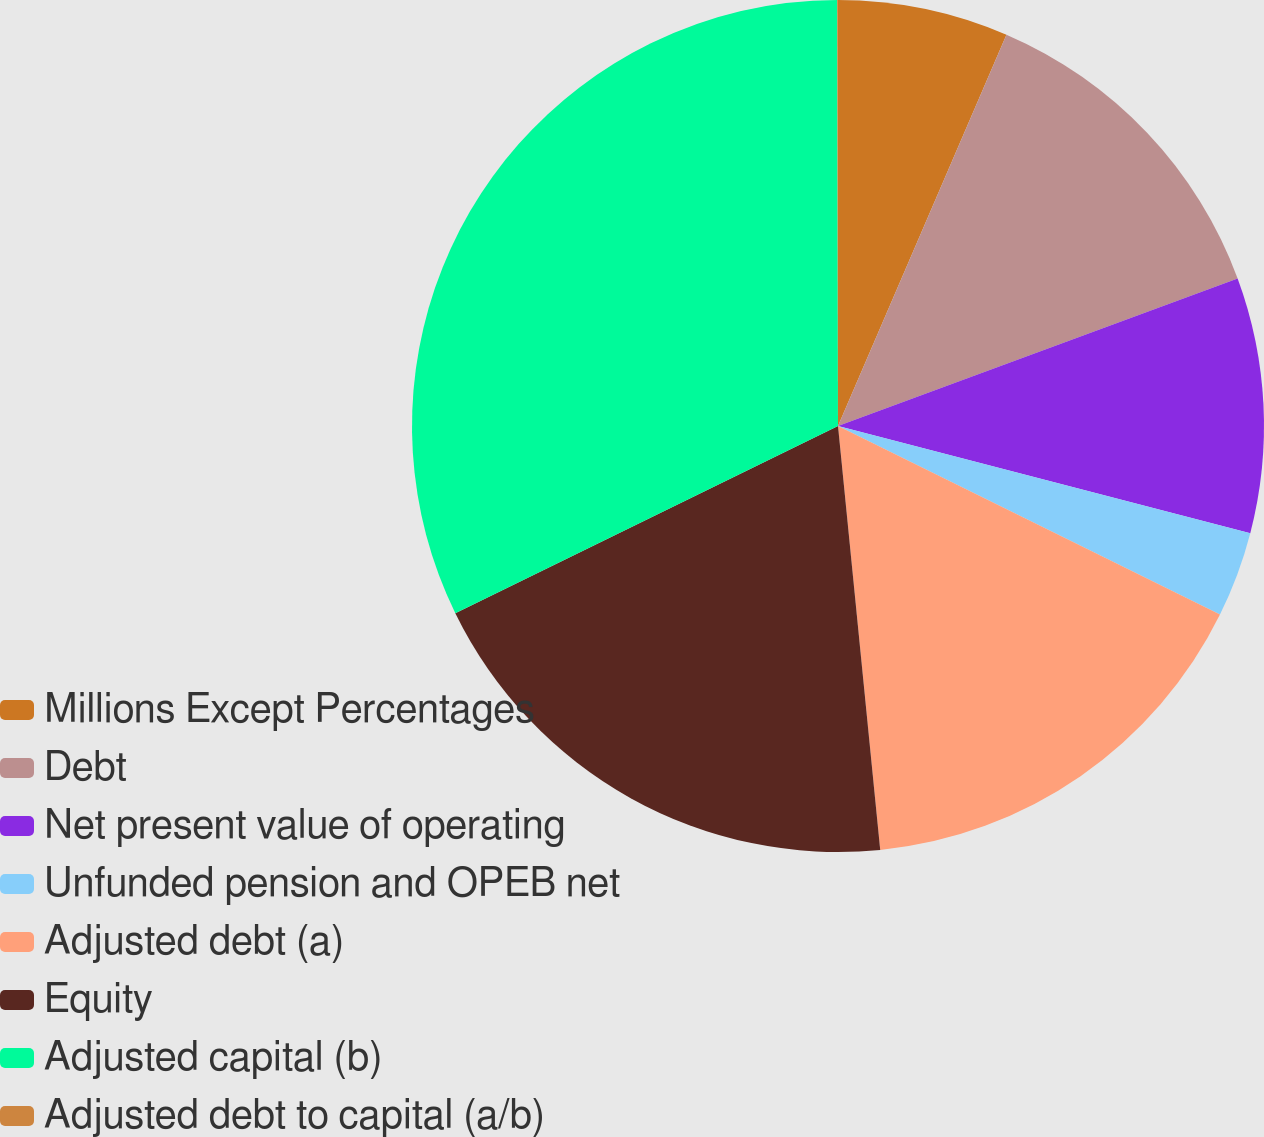<chart> <loc_0><loc_0><loc_500><loc_500><pie_chart><fcel>Millions Except Percentages<fcel>Debt<fcel>Net present value of operating<fcel>Unfunded pension and OPEB net<fcel>Adjusted debt (a)<fcel>Equity<fcel>Adjusted capital (b)<fcel>Adjusted debt to capital (a/b)<nl><fcel>6.47%<fcel>12.9%<fcel>9.68%<fcel>3.25%<fcel>16.12%<fcel>19.34%<fcel>32.21%<fcel>0.03%<nl></chart> 